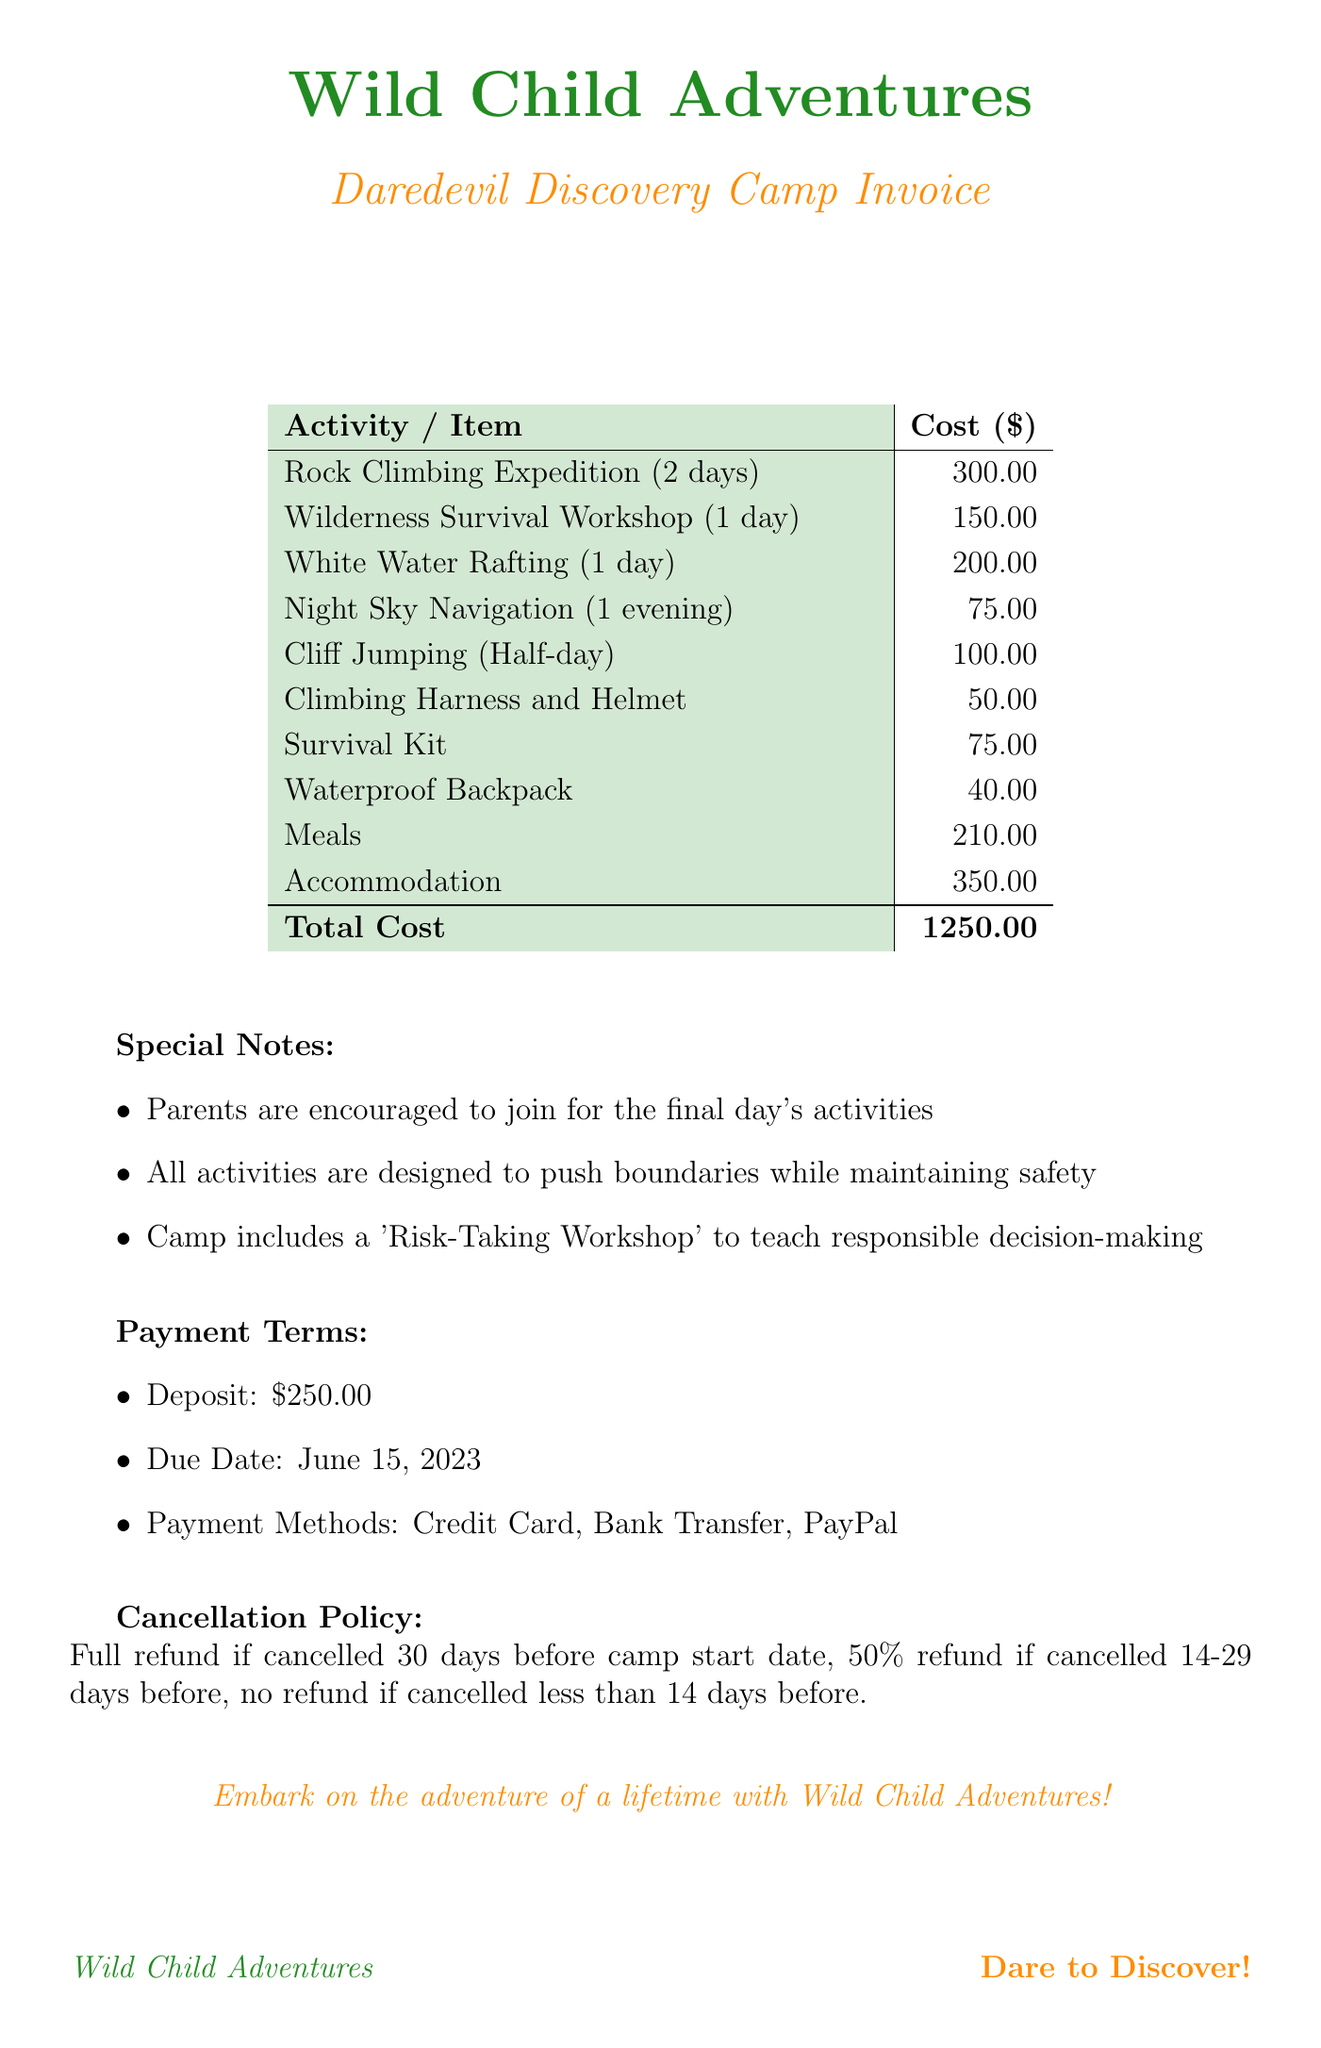What is the name of the camp? The camp is specifically named "Daredevil Discovery Camp."
Answer: Daredevil Discovery Camp What is the total cost of the camp? The total cost is listed clearly in the document as the final amount owed.
Answer: 1250.00 How many days does the camp last? The duration of the camp is mentioned explicitly in the document.
Answer: 7 days What activities are included on the final day? The special notes indicate a specific mention of what is encouraged for parents on the final day's activities.
Answer: Parents are encouraged to join What is the cost of the Wilderness Survival Workshop? The cost for this specific activity is detailed in the pricing section of the invoice.
Answer: 150.00 What is the deposit amount required? The invoice lists a specific amount required as a deposit in the payment terms section.
Answer: 250.00 What equipment is provided that costs $50? The invoice lists specific equipment along with their costs, leading to this particular item.
Answer: Climbing Harness and Helmet What is the due date for the payment? The due date for all payments is clearly stated in the payment terms section.
Answer: June 15, 2023 What is the cancellation policy for canceling less than 14 days before the camp? The document outlines specific refund conditions based on cancellation timing.
Answer: No refund 